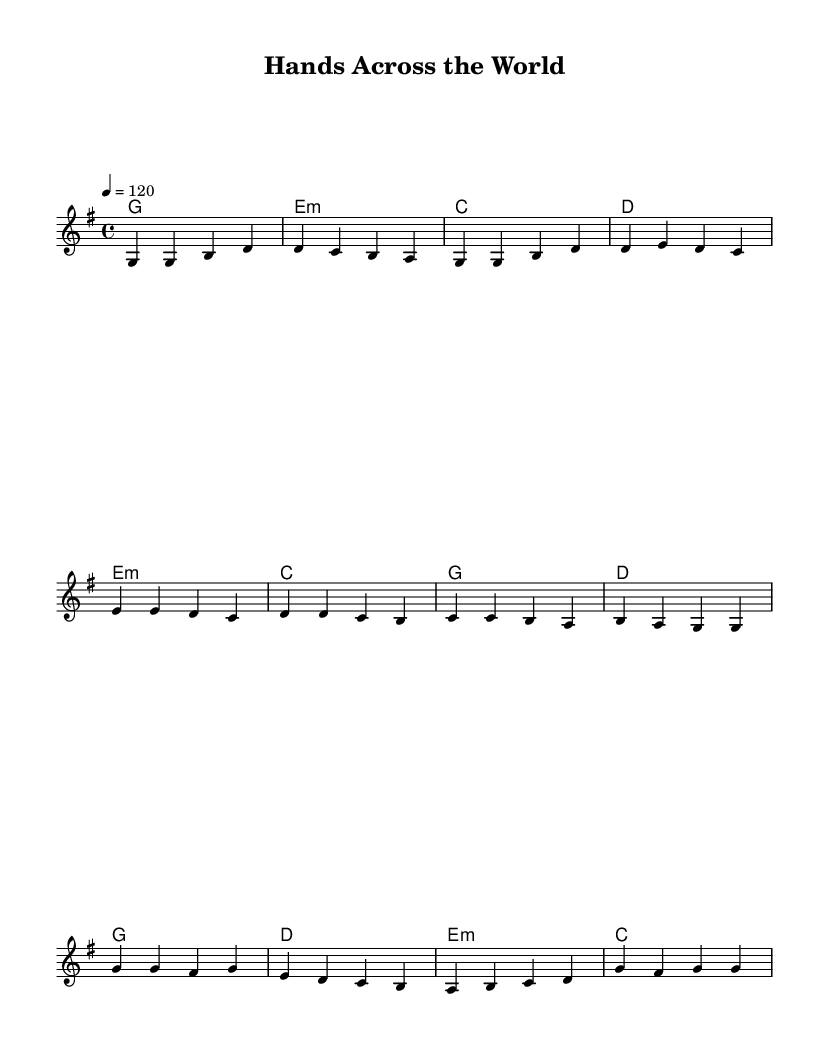What is the key signature of this music? The key is G major, which has one sharp (F#) indicated by the key signature at the beginning of the staff.
Answer: G major What is the time signature of the piece? The time signature is 4/4, noted at the beginning of the score, indicating four beats per measure.
Answer: 4/4 What is the tempo marking of this music? The tempo is marked as quarter note equals 120, indicating how fast the piece should be played.
Answer: 120 How many measures are in the verse? The verse consists of four measures as each group of notes separated by the vertical lines represents a measure.
Answer: 4 What is the first word of the lyrics? The first word of the lyrics in the verse section is "In," which is indicated above the first note in the melody.
Answer: In Which section follows the pre-chorus? The chorus follows the pre-chorus, as indicated by the structure of the music, where the pre-chorus ends and the chorus begins.
Answer: Chorus What chord is played during the chorus? The chord played during the chorus is G major, indicated at the beginning of the chorus section below the melody.
Answer: G 